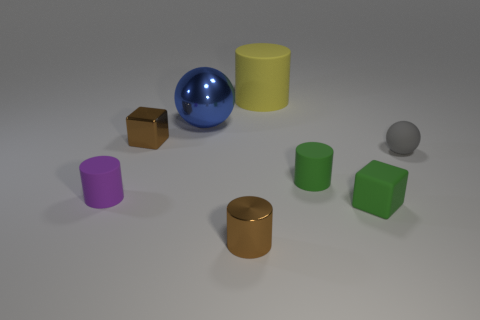Subtract all tiny green matte cylinders. How many cylinders are left? 3 Subtract all green cylinders. How many cylinders are left? 3 Subtract 2 cylinders. How many cylinders are left? 2 Subtract all green cylinders. Subtract all red spheres. How many cylinders are left? 3 Add 2 small gray matte spheres. How many objects exist? 10 Subtract all balls. How many objects are left? 6 Subtract 0 blue cubes. How many objects are left? 8 Subtract all brown blocks. Subtract all tiny matte cylinders. How many objects are left? 5 Add 3 green rubber cylinders. How many green rubber cylinders are left? 4 Add 6 brown cubes. How many brown cubes exist? 7 